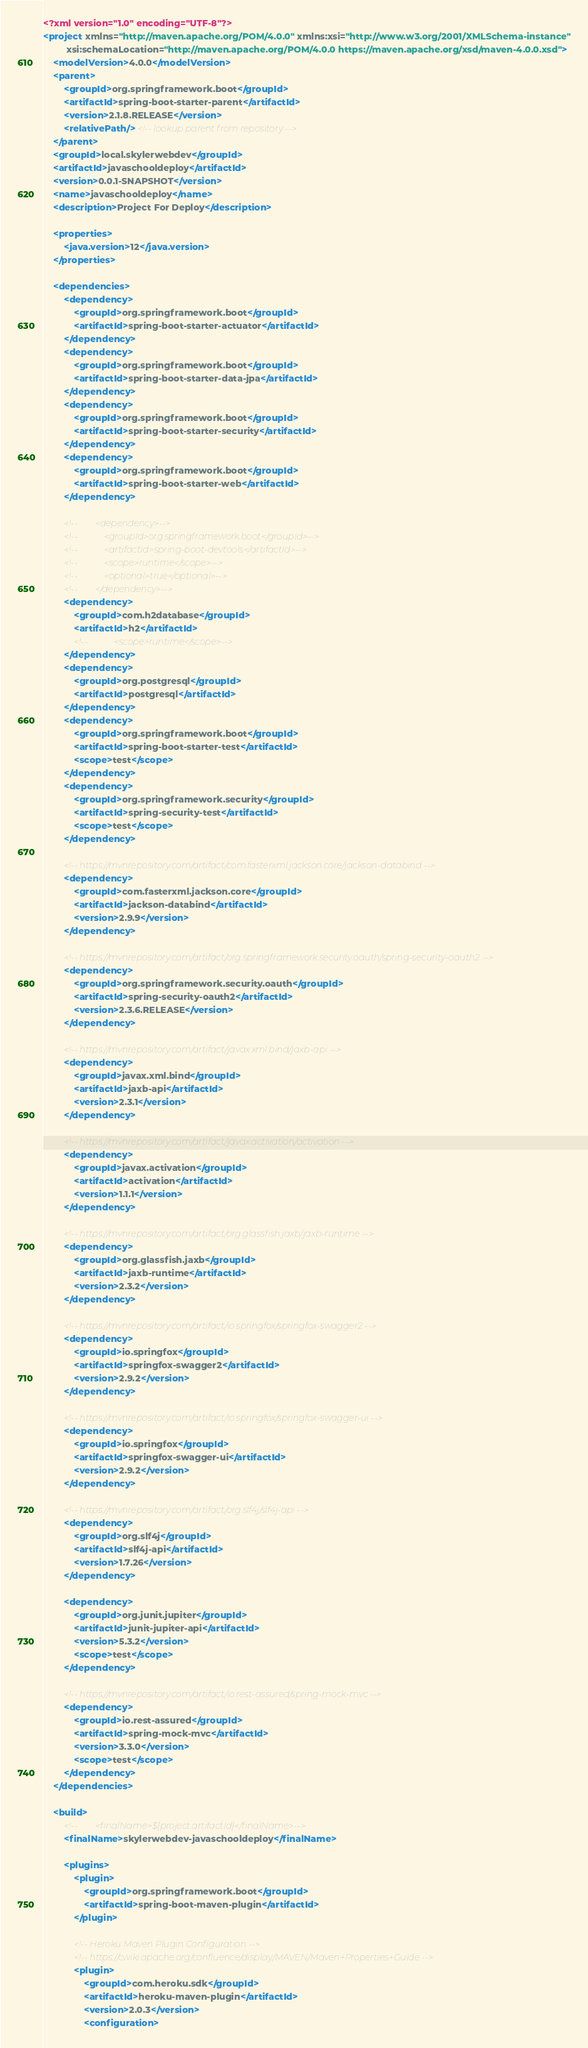Convert code to text. <code><loc_0><loc_0><loc_500><loc_500><_XML_><?xml version="1.0" encoding="UTF-8"?>
<project xmlns="http://maven.apache.org/POM/4.0.0" xmlns:xsi="http://www.w3.org/2001/XMLSchema-instance"
         xsi:schemaLocation="http://maven.apache.org/POM/4.0.0 https://maven.apache.org/xsd/maven-4.0.0.xsd">
    <modelVersion>4.0.0</modelVersion>
    <parent>
        <groupId>org.springframework.boot</groupId>
        <artifactId>spring-boot-starter-parent</artifactId>
        <version>2.1.8.RELEASE</version>
        <relativePath/> <!-- lookup parent from repository -->
    </parent>
    <groupId>local.skylerwebdev</groupId>
    <artifactId>javaschooldeploy</artifactId>
    <version>0.0.1-SNAPSHOT</version>
    <name>javaschooldeploy</name>
    <description>Project For Deploy</description>

    <properties>
        <java.version>12</java.version>
    </properties>

    <dependencies>
        <dependency>
            <groupId>org.springframework.boot</groupId>
            <artifactId>spring-boot-starter-actuator</artifactId>
        </dependency>
        <dependency>
            <groupId>org.springframework.boot</groupId>
            <artifactId>spring-boot-starter-data-jpa</artifactId>
        </dependency>
        <dependency>
            <groupId>org.springframework.boot</groupId>
            <artifactId>spring-boot-starter-security</artifactId>
        </dependency>
        <dependency>
            <groupId>org.springframework.boot</groupId>
            <artifactId>spring-boot-starter-web</artifactId>
        </dependency>

        <!--        <dependency>-->
        <!--            <groupId>org.springframework.boot</groupId>-->
        <!--            <artifactId>spring-boot-devtools</artifactId>-->
        <!--            <scope>runtime</scope>-->
        <!--            <optional>true</optional>-->
        <!--        </dependency>-->
        <dependency>
            <groupId>com.h2database</groupId>
            <artifactId>h2</artifactId>
            <!--            <scope>runtime</scope>-->
        </dependency>
        <dependency>
            <groupId>org.postgresql</groupId>
            <artifactId>postgresql</artifactId>
        </dependency>
        <dependency>
            <groupId>org.springframework.boot</groupId>
            <artifactId>spring-boot-starter-test</artifactId>
            <scope>test</scope>
        </dependency>
        <dependency>
            <groupId>org.springframework.security</groupId>
            <artifactId>spring-security-test</artifactId>
            <scope>test</scope>
        </dependency>

        <!-- https://mvnrepository.com/artifact/com.fasterxml.jackson.core/jackson-databind -->
        <dependency>
            <groupId>com.fasterxml.jackson.core</groupId>
            <artifactId>jackson-databind</artifactId>
            <version>2.9.9</version>
        </dependency>

        <!-- https://mvnrepository.com/artifact/org.springframework.security.oauth/spring-security-oauth2 -->
        <dependency>
            <groupId>org.springframework.security.oauth</groupId>
            <artifactId>spring-security-oauth2</artifactId>
            <version>2.3.6.RELEASE</version>
        </dependency>

        <!-- https://mvnrepository.com/artifact/javax.xml.bind/jaxb-api -->
        <dependency>
            <groupId>javax.xml.bind</groupId>
            <artifactId>jaxb-api</artifactId>
            <version>2.3.1</version>
        </dependency>

        <!-- https://mvnrepository.com/artifact/javax.activation/activation -->
        <dependency>
            <groupId>javax.activation</groupId>
            <artifactId>activation</artifactId>
            <version>1.1.1</version>
        </dependency>

        <!-- https://mvnrepository.com/artifact/org.glassfish.jaxb/jaxb-runtime -->
        <dependency>
            <groupId>org.glassfish.jaxb</groupId>
            <artifactId>jaxb-runtime</artifactId>
            <version>2.3.2</version>
        </dependency>

        <!-- https://mvnrepository.com/artifact/io.springfox/springfox-swagger2 -->
        <dependency>
            <groupId>io.springfox</groupId>
            <artifactId>springfox-swagger2</artifactId>
            <version>2.9.2</version>
        </dependency>

        <!-- https://mvnrepository.com/artifact/io.springfox/springfox-swagger-ui -->
        <dependency>
            <groupId>io.springfox</groupId>
            <artifactId>springfox-swagger-ui</artifactId>
            <version>2.9.2</version>
        </dependency>

        <!-- https://mvnrepository.com/artifact/org.slf4j/slf4j-api -->
        <dependency>
            <groupId>org.slf4j</groupId>
            <artifactId>slf4j-api</artifactId>
            <version>1.7.26</version>
        </dependency>

        <dependency>
            <groupId>org.junit.jupiter</groupId>
            <artifactId>junit-jupiter-api</artifactId>
            <version>5.3.2</version>
            <scope>test</scope>
        </dependency>

        <!-- https://mvnrepository.com/artifact/io.rest-assured/spring-mock-mvc -->
        <dependency>
            <groupId>io.rest-assured</groupId>
            <artifactId>spring-mock-mvc</artifactId>
            <version>3.3.0</version>
            <scope>test</scope>
        </dependency>
    </dependencies>

    <build>
        <!--        <finalName>${project.artifactId}</finalName>-->
        <finalName>skylerwebdev-javaschooldeploy</finalName>

        <plugins>
            <plugin>
                <groupId>org.springframework.boot</groupId>
                <artifactId>spring-boot-maven-plugin</artifactId>
            </plugin>

            <!-- Heroku Maven Plugin Configuration -->
            <!-- https://cwiki.apache.org/confluence/display/MAVEN/Maven+Properties+Guide -->
            <plugin>
                <groupId>com.heroku.sdk</groupId>
                <artifactId>heroku-maven-plugin</artifactId>
                <version>2.0.3</version>
                <configuration></code> 